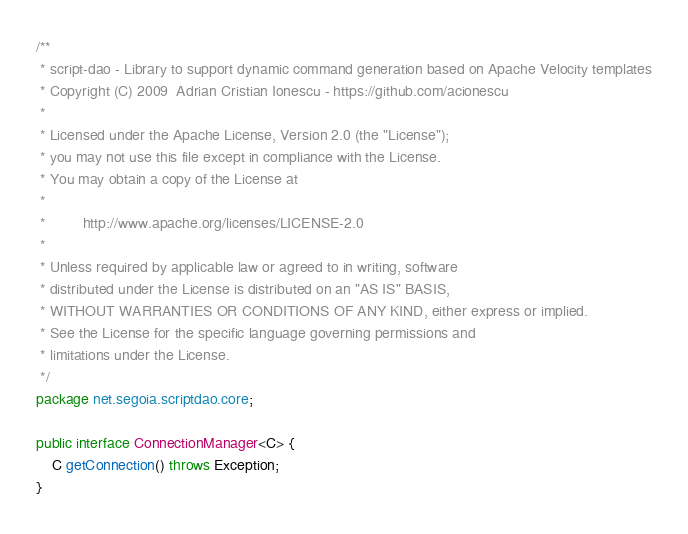<code> <loc_0><loc_0><loc_500><loc_500><_Java_>/**
 * script-dao - Library to support dynamic command generation based on Apache Velocity templates
 * Copyright (C) 2009  Adrian Cristian Ionescu - https://github.com/acionescu
 *
 * Licensed under the Apache License, Version 2.0 (the "License");
 * you may not use this file except in compliance with the License.
 * You may obtain a copy of the License at
 *
 *         http://www.apache.org/licenses/LICENSE-2.0
 *
 * Unless required by applicable law or agreed to in writing, software
 * distributed under the License is distributed on an "AS IS" BASIS,
 * WITHOUT WARRANTIES OR CONDITIONS OF ANY KIND, either express or implied.
 * See the License for the specific language governing permissions and
 * limitations under the License.
 */
package net.segoia.scriptdao.core;

public interface ConnectionManager<C> {
    C getConnection() throws Exception;
}
</code> 